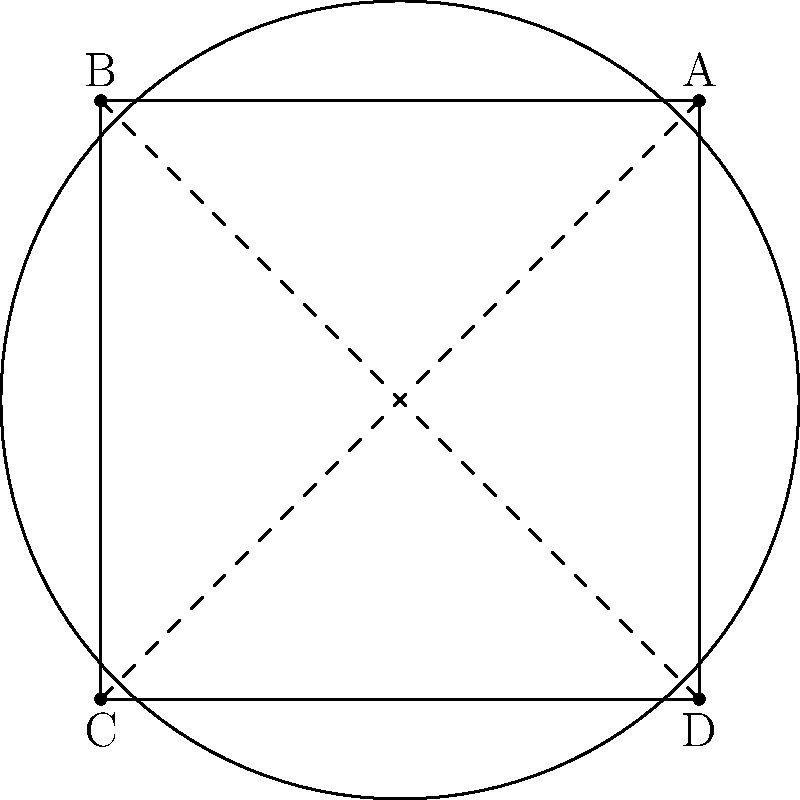In a hyperbolic city layout, the curvature of space affects the perception of straight lines. If a city planner designs four equidistant points A, B, C, and D on a hyperbolic plane as shown in the diagram, what is the sum of the interior angles of the quadrilateral ABCD? To understand this problem, let's follow these steps:

1. In Euclidean geometry, the sum of interior angles of a quadrilateral is always 360°.

2. However, in hyperbolic geometry, the sum of interior angles of a polygon is always less than what it would be in Euclidean geometry.

3. The defect (difference from Euclidean sum) is proportional to the area of the polygon and the curvature of the space.

4. In hyperbolic geometry, the defect for a quadrilateral is given by the formula:

   $$\text{Defect} = 2\pi - (\alpha + \beta + \gamma + \delta)$$

   where $\alpha$, $\beta$, $\gamma$, and $\delta$ are the interior angles of the quadrilateral.

5. The defect is also equal to the area of the quadrilateral multiplied by the absolute value of the Gaussian curvature $K$:

   $$\text{Defect} = |K| \cdot \text{Area}$$

6. In a hyperbolic plane, $K$ is constant and negative. Let's assume $|K| = 1$ for simplicity.

7. The area of this quadrilateral in hyperbolic space is greater than 0 but less than $2\pi$ (the area of an ideal quadrilateral, which is the maximum possible).

8. Therefore, the defect is greater than 0 but less than $2\pi$.

9. Consequently, the sum of the interior angles must be less than 360° (or $2\pi$ radians) but greater than 0°.
Answer: Less than 360° 